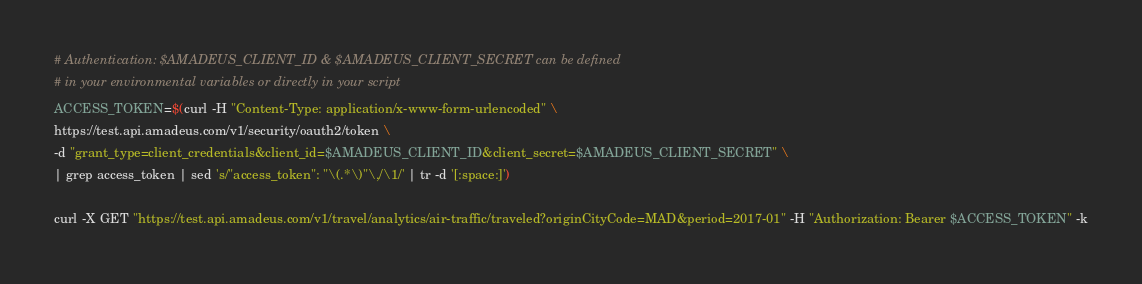<code> <loc_0><loc_0><loc_500><loc_500><_Bash_># Authentication: $AMADEUS_CLIENT_ID & $AMADEUS_CLIENT_SECRET can be defined
# in your environmental variables or directly in your script
ACCESS_TOKEN=$(curl -H "Content-Type: application/x-www-form-urlencoded" \
https://test.api.amadeus.com/v1/security/oauth2/token \
-d "grant_type=client_credentials&client_id=$AMADEUS_CLIENT_ID&client_secret=$AMADEUS_CLIENT_SECRET" \
| grep access_token | sed 's/"access_token": "\(.*\)"\,/\1/' | tr -d '[:space:]')

curl -X GET "https://test.api.amadeus.com/v1/travel/analytics/air-traffic/traveled?originCityCode=MAD&period=2017-01" -H "Authorization: Bearer $ACCESS_TOKEN" -k</code> 